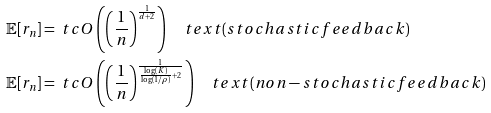<formula> <loc_0><loc_0><loc_500><loc_500>\mathbb { E } [ r _ { n } ] & = \ t c O \left ( \left ( \frac { 1 } { n } \right ) ^ { \frac { 1 } { d + 2 } } \right ) \quad t e x t { ( s t o c h a s t i c f e e d b a c k ) } \\ \mathbb { E } [ r _ { n } ] & = \ t c O \left ( \left ( \frac { 1 } { n } \right ) ^ { \frac { 1 } { \frac { \log ( K ) } { \log ( 1 / \rho ) } + 2 } } \right ) \quad t e x t { ( n o n - s t o c h a s t i c f e e d b a c k ) }</formula> 